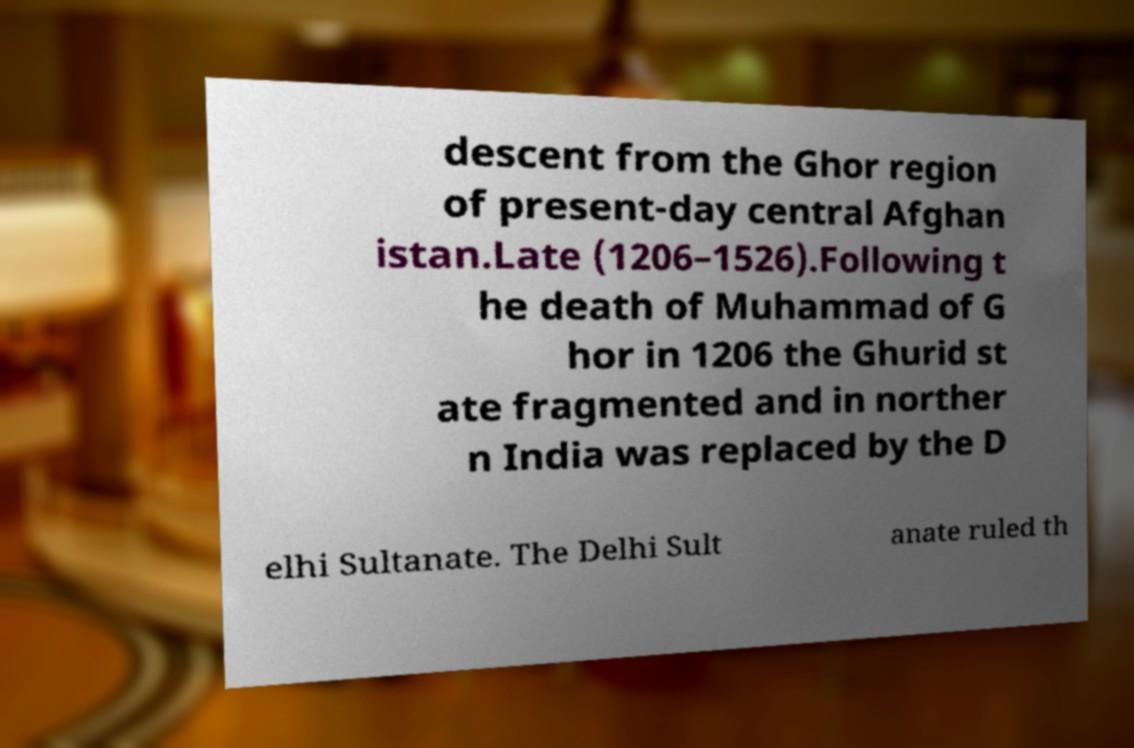I need the written content from this picture converted into text. Can you do that? descent from the Ghor region of present-day central Afghan istan.Late (1206–1526).Following t he death of Muhammad of G hor in 1206 the Ghurid st ate fragmented and in norther n India was replaced by the D elhi Sultanate. The Delhi Sult anate ruled th 